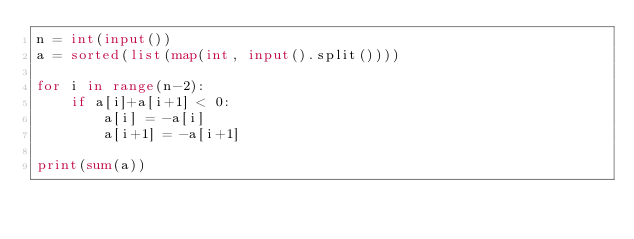Convert code to text. <code><loc_0><loc_0><loc_500><loc_500><_Python_>n = int(input())
a = sorted(list(map(int, input().split())))

for i in range(n-2):
    if a[i]+a[i+1] < 0:
        a[i] = -a[i]
        a[i+1] = -a[i+1]

print(sum(a))</code> 